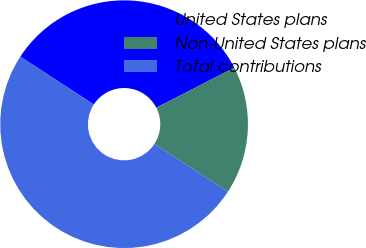Convert chart to OTSL. <chart><loc_0><loc_0><loc_500><loc_500><pie_chart><fcel>United States plans<fcel>Non-United States plans<fcel>Total contributions<nl><fcel>33.28%<fcel>16.72%<fcel>50.0%<nl></chart> 